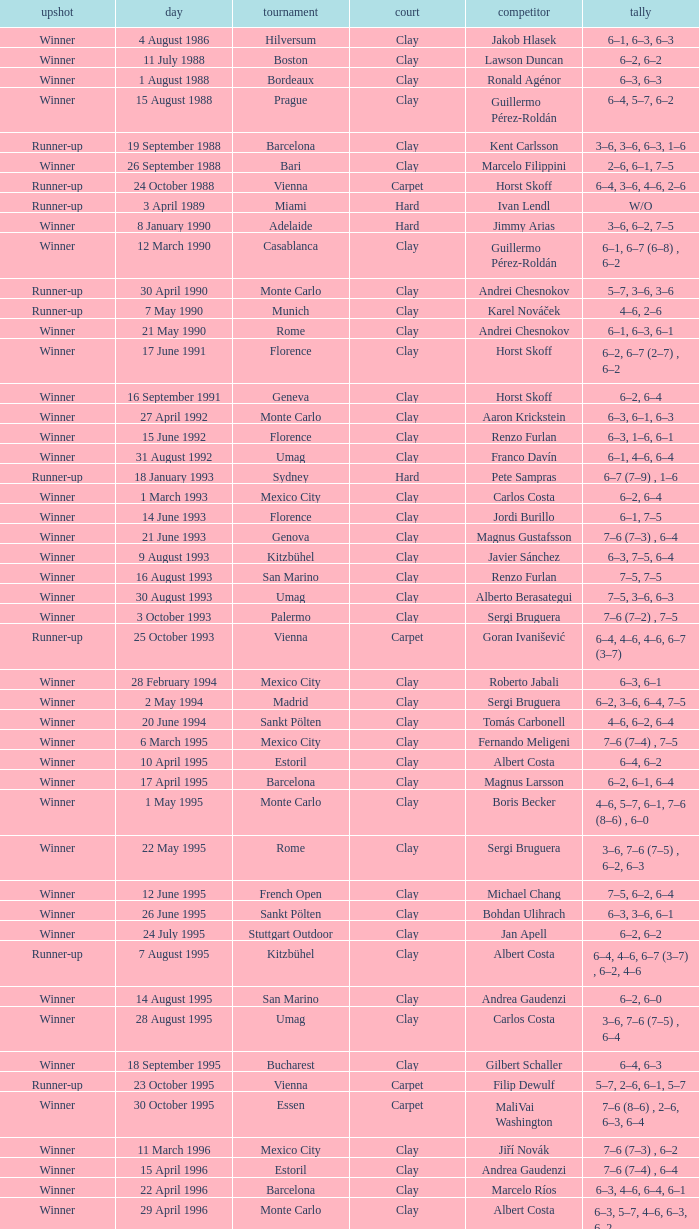Who is the opponent when the surface is clay, the outcome is winner and the championship is estoril on 15 april 1996? Andrea Gaudenzi. 